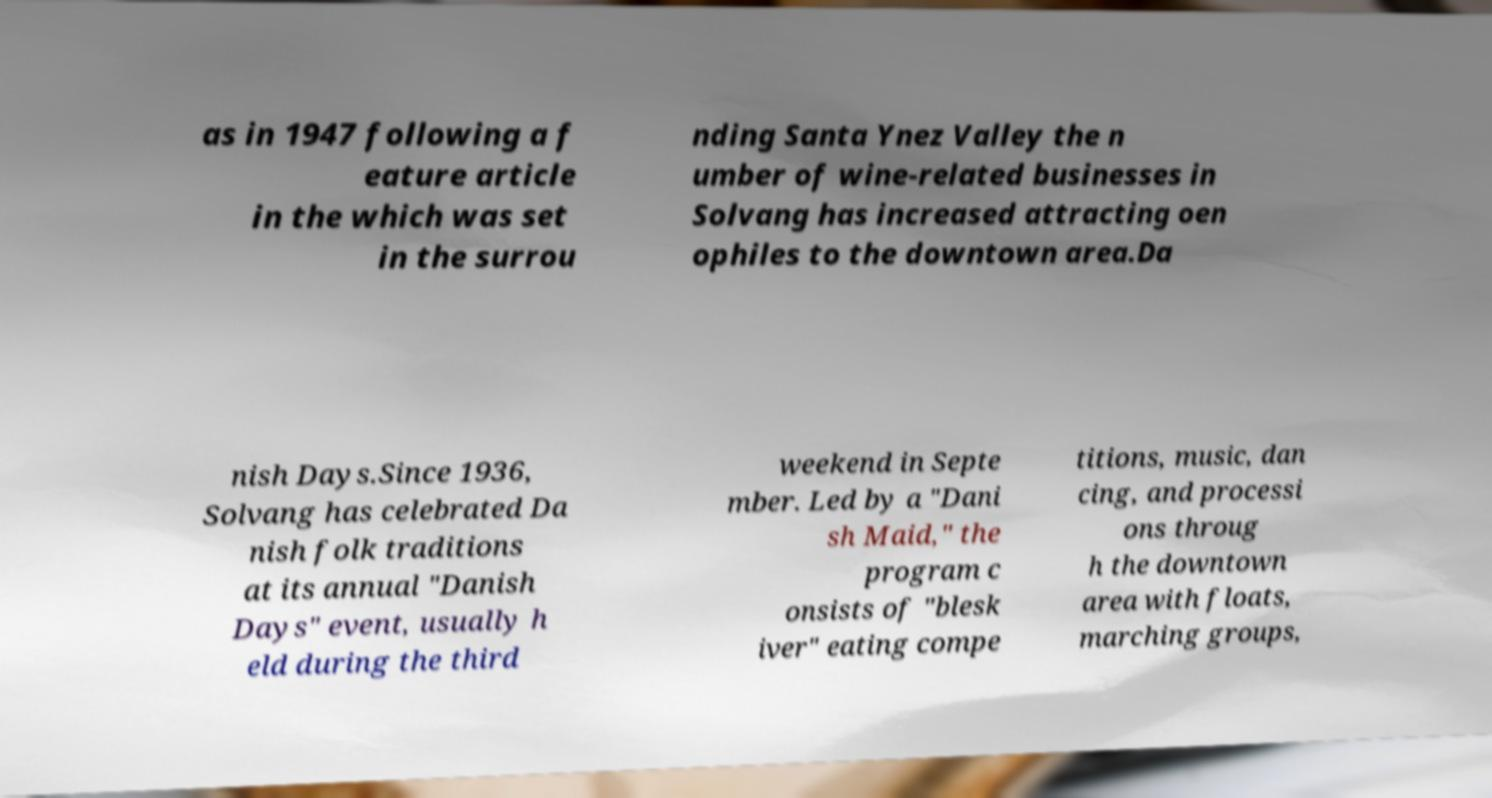Please read and relay the text visible in this image. What does it say? as in 1947 following a f eature article in the which was set in the surrou nding Santa Ynez Valley the n umber of wine-related businesses in Solvang has increased attracting oen ophiles to the downtown area.Da nish Days.Since 1936, Solvang has celebrated Da nish folk traditions at its annual "Danish Days" event, usually h eld during the third weekend in Septe mber. Led by a "Dani sh Maid," the program c onsists of "blesk iver" eating compe titions, music, dan cing, and processi ons throug h the downtown area with floats, marching groups, 